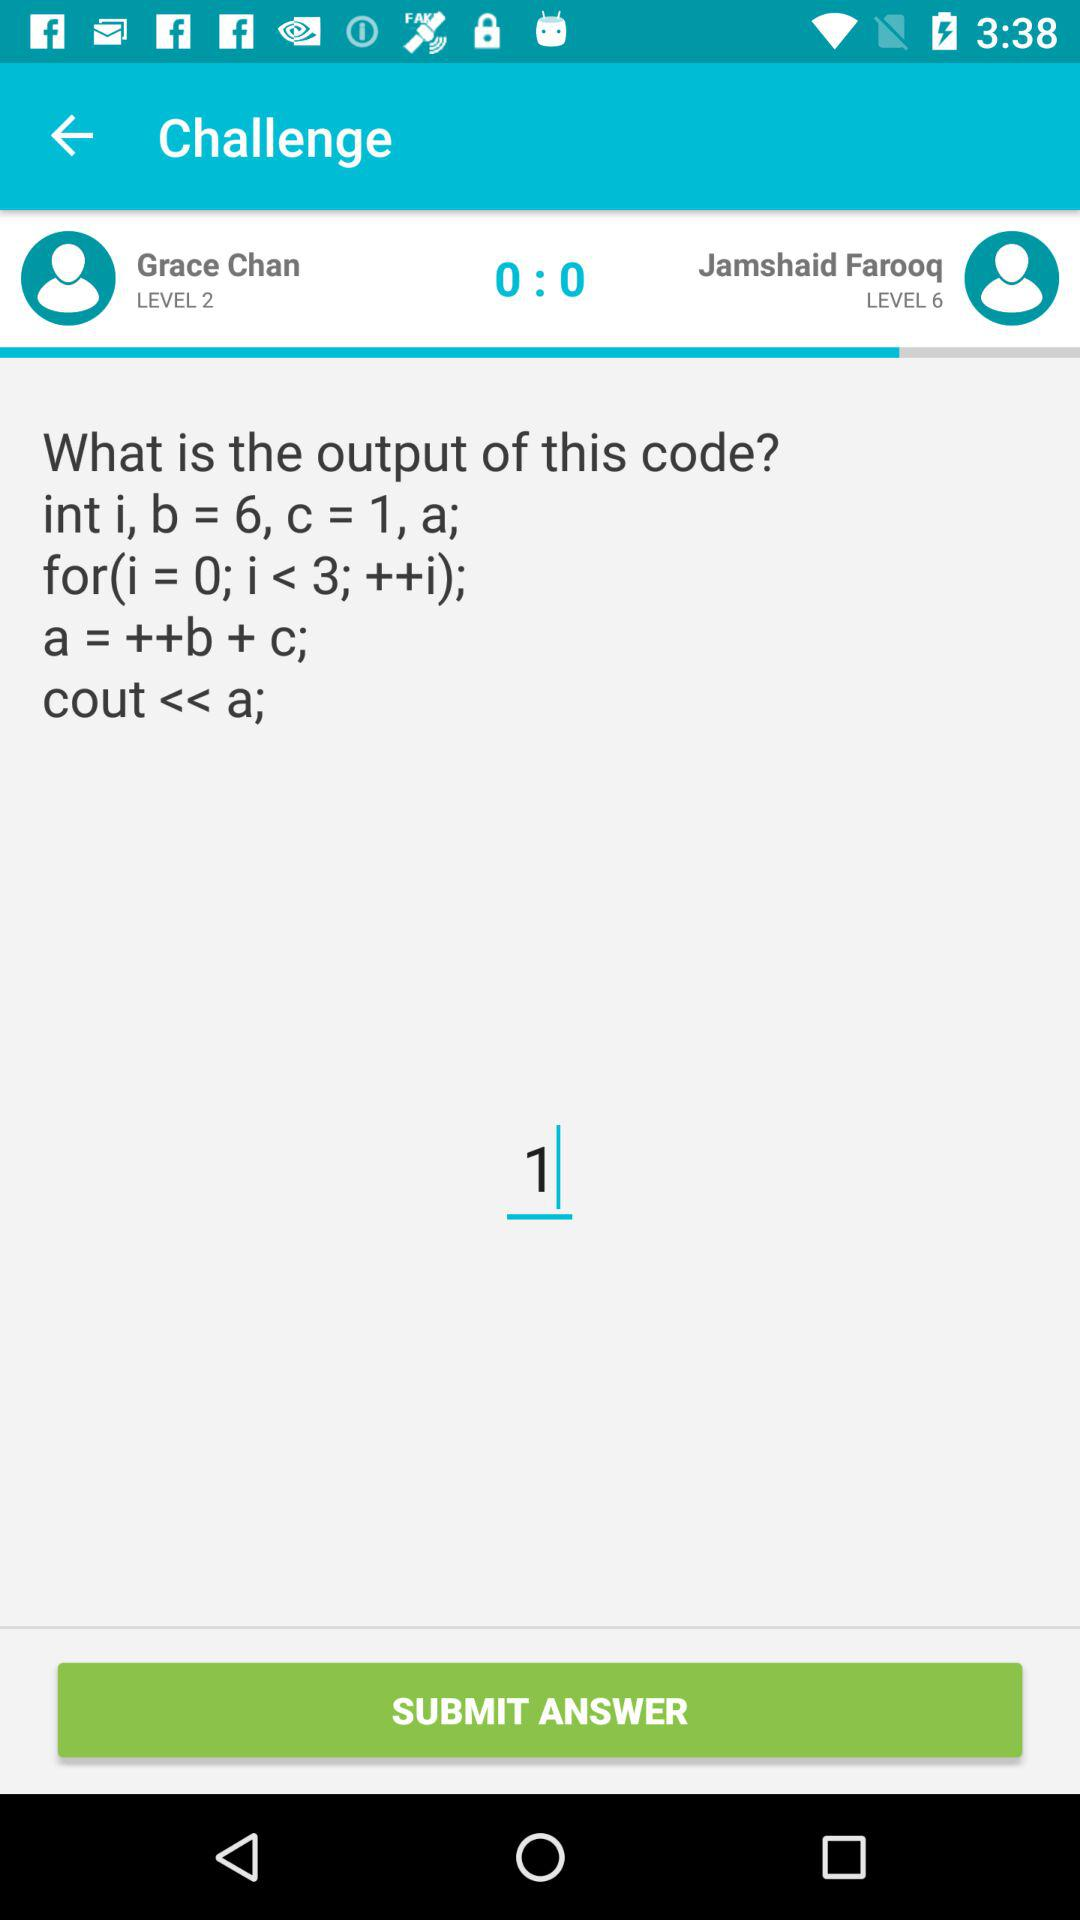What is the difference between the level of Grace Chan and Jamshaid Farooq?
Answer the question using a single word or phrase. 4 